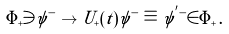<formula> <loc_0><loc_0><loc_500><loc_500>{ \mathbf \Phi } _ { + } \ni \psi ^ { - } \to U _ { + } ( t ) \psi ^ { - } \equiv \psi ^ { ^ { \prime } - } \in { \mathbf \Phi } _ { + } \, .</formula> 